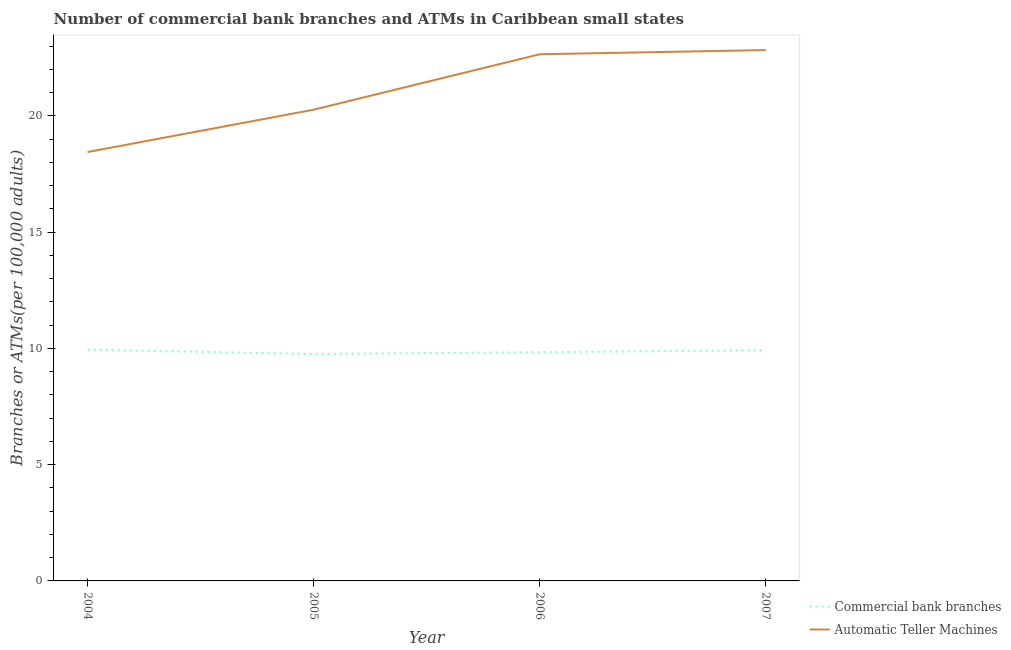How many different coloured lines are there?
Ensure brevity in your answer.  2. Does the line corresponding to number of commercal bank branches intersect with the line corresponding to number of atms?
Your response must be concise. No. Is the number of lines equal to the number of legend labels?
Keep it short and to the point. Yes. What is the number of atms in 2006?
Ensure brevity in your answer.  22.65. Across all years, what is the maximum number of commercal bank branches?
Make the answer very short. 9.95. Across all years, what is the minimum number of commercal bank branches?
Your response must be concise. 9.76. In which year was the number of commercal bank branches minimum?
Ensure brevity in your answer.  2005. What is the total number of atms in the graph?
Make the answer very short. 84.19. What is the difference between the number of commercal bank branches in 2004 and that in 2006?
Ensure brevity in your answer.  0.11. What is the difference between the number of atms in 2006 and the number of commercal bank branches in 2007?
Your response must be concise. 12.73. What is the average number of commercal bank branches per year?
Give a very brief answer. 9.87. In the year 2004, what is the difference between the number of atms and number of commercal bank branches?
Offer a terse response. 8.5. In how many years, is the number of atms greater than 6?
Your response must be concise. 4. What is the ratio of the number of commercal bank branches in 2004 to that in 2005?
Give a very brief answer. 1.02. Is the number of commercal bank branches in 2004 less than that in 2007?
Make the answer very short. No. What is the difference between the highest and the second highest number of atms?
Make the answer very short. 0.18. What is the difference between the highest and the lowest number of commercal bank branches?
Provide a succinct answer. 0.19. In how many years, is the number of atms greater than the average number of atms taken over all years?
Your response must be concise. 2. Is the sum of the number of atms in 2004 and 2006 greater than the maximum number of commercal bank branches across all years?
Provide a short and direct response. Yes. Does the number of commercal bank branches monotonically increase over the years?
Your answer should be very brief. No. Is the number of atms strictly greater than the number of commercal bank branches over the years?
Offer a terse response. Yes. Is the number of atms strictly less than the number of commercal bank branches over the years?
Your response must be concise. No. What is the difference between two consecutive major ticks on the Y-axis?
Ensure brevity in your answer.  5. Are the values on the major ticks of Y-axis written in scientific E-notation?
Keep it short and to the point. No. Where does the legend appear in the graph?
Offer a terse response. Bottom right. How many legend labels are there?
Your answer should be compact. 2. How are the legend labels stacked?
Your answer should be compact. Vertical. What is the title of the graph?
Offer a very short reply. Number of commercial bank branches and ATMs in Caribbean small states. Does "Electricity" appear as one of the legend labels in the graph?
Make the answer very short. No. What is the label or title of the X-axis?
Offer a terse response. Year. What is the label or title of the Y-axis?
Your response must be concise. Branches or ATMs(per 100,0 adults). What is the Branches or ATMs(per 100,000 adults) in Commercial bank branches in 2004?
Your response must be concise. 9.95. What is the Branches or ATMs(per 100,000 adults) of Automatic Teller Machines in 2004?
Provide a short and direct response. 18.44. What is the Branches or ATMs(per 100,000 adults) of Commercial bank branches in 2005?
Offer a very short reply. 9.76. What is the Branches or ATMs(per 100,000 adults) in Automatic Teller Machines in 2005?
Offer a very short reply. 20.26. What is the Branches or ATMs(per 100,000 adults) of Commercial bank branches in 2006?
Provide a succinct answer. 9.84. What is the Branches or ATMs(per 100,000 adults) in Automatic Teller Machines in 2006?
Offer a very short reply. 22.65. What is the Branches or ATMs(per 100,000 adults) of Commercial bank branches in 2007?
Offer a very short reply. 9.92. What is the Branches or ATMs(per 100,000 adults) of Automatic Teller Machines in 2007?
Make the answer very short. 22.83. Across all years, what is the maximum Branches or ATMs(per 100,000 adults) in Commercial bank branches?
Offer a very short reply. 9.95. Across all years, what is the maximum Branches or ATMs(per 100,000 adults) in Automatic Teller Machines?
Offer a terse response. 22.83. Across all years, what is the minimum Branches or ATMs(per 100,000 adults) in Commercial bank branches?
Provide a short and direct response. 9.76. Across all years, what is the minimum Branches or ATMs(per 100,000 adults) in Automatic Teller Machines?
Offer a very short reply. 18.44. What is the total Branches or ATMs(per 100,000 adults) in Commercial bank branches in the graph?
Your answer should be compact. 39.46. What is the total Branches or ATMs(per 100,000 adults) of Automatic Teller Machines in the graph?
Provide a succinct answer. 84.19. What is the difference between the Branches or ATMs(per 100,000 adults) of Commercial bank branches in 2004 and that in 2005?
Give a very brief answer. 0.19. What is the difference between the Branches or ATMs(per 100,000 adults) of Automatic Teller Machines in 2004 and that in 2005?
Make the answer very short. -1.82. What is the difference between the Branches or ATMs(per 100,000 adults) of Commercial bank branches in 2004 and that in 2006?
Keep it short and to the point. 0.11. What is the difference between the Branches or ATMs(per 100,000 adults) of Automatic Teller Machines in 2004 and that in 2006?
Your response must be concise. -4.21. What is the difference between the Branches or ATMs(per 100,000 adults) in Commercial bank branches in 2004 and that in 2007?
Offer a very short reply. 0.02. What is the difference between the Branches or ATMs(per 100,000 adults) of Automatic Teller Machines in 2004 and that in 2007?
Provide a short and direct response. -4.38. What is the difference between the Branches or ATMs(per 100,000 adults) of Commercial bank branches in 2005 and that in 2006?
Offer a terse response. -0.08. What is the difference between the Branches or ATMs(per 100,000 adults) of Automatic Teller Machines in 2005 and that in 2006?
Provide a short and direct response. -2.38. What is the difference between the Branches or ATMs(per 100,000 adults) of Commercial bank branches in 2005 and that in 2007?
Give a very brief answer. -0.16. What is the difference between the Branches or ATMs(per 100,000 adults) of Automatic Teller Machines in 2005 and that in 2007?
Give a very brief answer. -2.56. What is the difference between the Branches or ATMs(per 100,000 adults) in Commercial bank branches in 2006 and that in 2007?
Your response must be concise. -0.09. What is the difference between the Branches or ATMs(per 100,000 adults) of Automatic Teller Machines in 2006 and that in 2007?
Offer a terse response. -0.18. What is the difference between the Branches or ATMs(per 100,000 adults) in Commercial bank branches in 2004 and the Branches or ATMs(per 100,000 adults) in Automatic Teller Machines in 2005?
Keep it short and to the point. -10.32. What is the difference between the Branches or ATMs(per 100,000 adults) in Commercial bank branches in 2004 and the Branches or ATMs(per 100,000 adults) in Automatic Teller Machines in 2006?
Your response must be concise. -12.7. What is the difference between the Branches or ATMs(per 100,000 adults) of Commercial bank branches in 2004 and the Branches or ATMs(per 100,000 adults) of Automatic Teller Machines in 2007?
Keep it short and to the point. -12.88. What is the difference between the Branches or ATMs(per 100,000 adults) of Commercial bank branches in 2005 and the Branches or ATMs(per 100,000 adults) of Automatic Teller Machines in 2006?
Your response must be concise. -12.89. What is the difference between the Branches or ATMs(per 100,000 adults) of Commercial bank branches in 2005 and the Branches or ATMs(per 100,000 adults) of Automatic Teller Machines in 2007?
Provide a succinct answer. -13.07. What is the difference between the Branches or ATMs(per 100,000 adults) of Commercial bank branches in 2006 and the Branches or ATMs(per 100,000 adults) of Automatic Teller Machines in 2007?
Offer a very short reply. -12.99. What is the average Branches or ATMs(per 100,000 adults) of Commercial bank branches per year?
Provide a succinct answer. 9.87. What is the average Branches or ATMs(per 100,000 adults) of Automatic Teller Machines per year?
Provide a succinct answer. 21.05. In the year 2004, what is the difference between the Branches or ATMs(per 100,000 adults) of Commercial bank branches and Branches or ATMs(per 100,000 adults) of Automatic Teller Machines?
Keep it short and to the point. -8.5. In the year 2005, what is the difference between the Branches or ATMs(per 100,000 adults) of Commercial bank branches and Branches or ATMs(per 100,000 adults) of Automatic Teller Machines?
Offer a very short reply. -10.51. In the year 2006, what is the difference between the Branches or ATMs(per 100,000 adults) of Commercial bank branches and Branches or ATMs(per 100,000 adults) of Automatic Teller Machines?
Your response must be concise. -12.81. In the year 2007, what is the difference between the Branches or ATMs(per 100,000 adults) of Commercial bank branches and Branches or ATMs(per 100,000 adults) of Automatic Teller Machines?
Give a very brief answer. -12.91. What is the ratio of the Branches or ATMs(per 100,000 adults) in Commercial bank branches in 2004 to that in 2005?
Provide a succinct answer. 1.02. What is the ratio of the Branches or ATMs(per 100,000 adults) of Automatic Teller Machines in 2004 to that in 2005?
Make the answer very short. 0.91. What is the ratio of the Branches or ATMs(per 100,000 adults) in Commercial bank branches in 2004 to that in 2006?
Your answer should be very brief. 1.01. What is the ratio of the Branches or ATMs(per 100,000 adults) of Automatic Teller Machines in 2004 to that in 2006?
Provide a succinct answer. 0.81. What is the ratio of the Branches or ATMs(per 100,000 adults) of Commercial bank branches in 2004 to that in 2007?
Offer a very short reply. 1. What is the ratio of the Branches or ATMs(per 100,000 adults) of Automatic Teller Machines in 2004 to that in 2007?
Offer a very short reply. 0.81. What is the ratio of the Branches or ATMs(per 100,000 adults) in Commercial bank branches in 2005 to that in 2006?
Provide a succinct answer. 0.99. What is the ratio of the Branches or ATMs(per 100,000 adults) in Automatic Teller Machines in 2005 to that in 2006?
Offer a terse response. 0.89. What is the ratio of the Branches or ATMs(per 100,000 adults) of Commercial bank branches in 2005 to that in 2007?
Offer a very short reply. 0.98. What is the ratio of the Branches or ATMs(per 100,000 adults) of Automatic Teller Machines in 2005 to that in 2007?
Your answer should be compact. 0.89. What is the difference between the highest and the second highest Branches or ATMs(per 100,000 adults) of Commercial bank branches?
Offer a very short reply. 0.02. What is the difference between the highest and the second highest Branches or ATMs(per 100,000 adults) in Automatic Teller Machines?
Give a very brief answer. 0.18. What is the difference between the highest and the lowest Branches or ATMs(per 100,000 adults) in Commercial bank branches?
Your answer should be very brief. 0.19. What is the difference between the highest and the lowest Branches or ATMs(per 100,000 adults) in Automatic Teller Machines?
Offer a terse response. 4.38. 